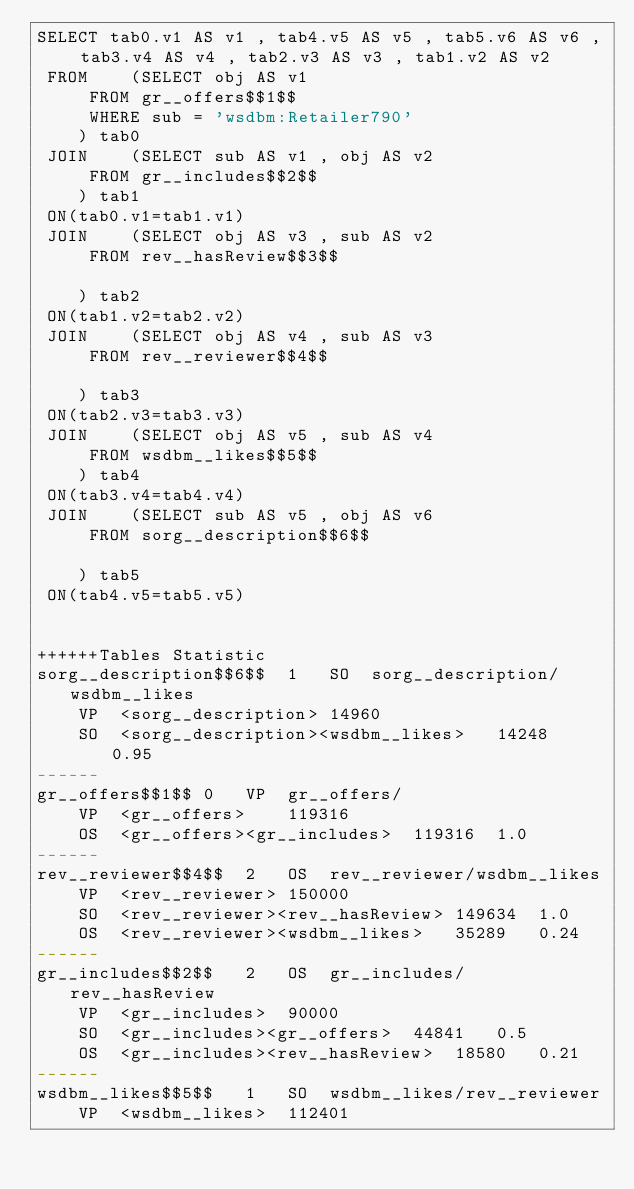<code> <loc_0><loc_0><loc_500><loc_500><_SQL_>SELECT tab0.v1 AS v1 , tab4.v5 AS v5 , tab5.v6 AS v6 , tab3.v4 AS v4 , tab2.v3 AS v3 , tab1.v2 AS v2 
 FROM    (SELECT obj AS v1 
	 FROM gr__offers$$1$$ 
	 WHERE sub = 'wsdbm:Retailer790'
	) tab0
 JOIN    (SELECT sub AS v1 , obj AS v2 
	 FROM gr__includes$$2$$
	) tab1
 ON(tab0.v1=tab1.v1)
 JOIN    (SELECT obj AS v3 , sub AS v2 
	 FROM rev__hasReview$$3$$
	
	) tab2
 ON(tab1.v2=tab2.v2)
 JOIN    (SELECT obj AS v4 , sub AS v3 
	 FROM rev__reviewer$$4$$
	
	) tab3
 ON(tab2.v3=tab3.v3)
 JOIN    (SELECT obj AS v5 , sub AS v4 
	 FROM wsdbm__likes$$5$$
	) tab4
 ON(tab3.v4=tab4.v4)
 JOIN    (SELECT sub AS v5 , obj AS v6 
	 FROM sorg__description$$6$$
	
	) tab5
 ON(tab4.v5=tab5.v5)


++++++Tables Statistic
sorg__description$$6$$	1	SO	sorg__description/wsdbm__likes
	VP	<sorg__description>	14960
	SO	<sorg__description><wsdbm__likes>	14248	0.95
------
gr__offers$$1$$	0	VP	gr__offers/
	VP	<gr__offers>	119316
	OS	<gr__offers><gr__includes>	119316	1.0
------
rev__reviewer$$4$$	2	OS	rev__reviewer/wsdbm__likes
	VP	<rev__reviewer>	150000
	SO	<rev__reviewer><rev__hasReview>	149634	1.0
	OS	<rev__reviewer><wsdbm__likes>	35289	0.24
------
gr__includes$$2$$	2	OS	gr__includes/rev__hasReview
	VP	<gr__includes>	90000
	SO	<gr__includes><gr__offers>	44841	0.5
	OS	<gr__includes><rev__hasReview>	18580	0.21
------
wsdbm__likes$$5$$	1	SO	wsdbm__likes/rev__reviewer
	VP	<wsdbm__likes>	112401</code> 